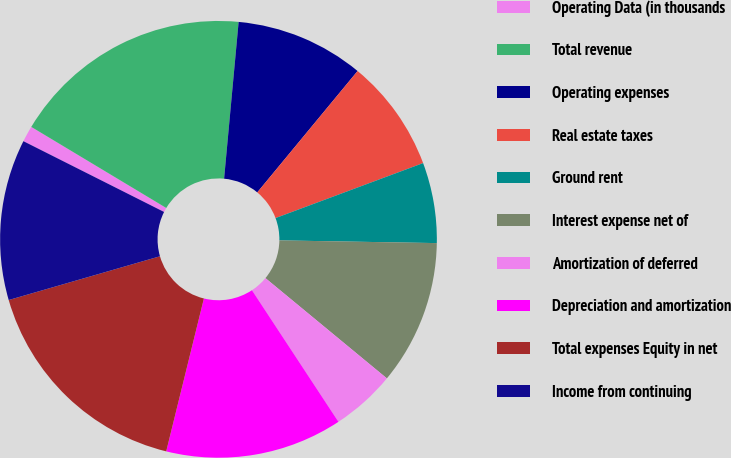Convert chart to OTSL. <chart><loc_0><loc_0><loc_500><loc_500><pie_chart><fcel>Operating Data (in thousands<fcel>Total revenue<fcel>Operating expenses<fcel>Real estate taxes<fcel>Ground rent<fcel>Interest expense net of<fcel>Amortization of deferred<fcel>Depreciation and amortization<fcel>Total expenses Equity in net<fcel>Income from continuing<nl><fcel>1.19%<fcel>17.86%<fcel>9.52%<fcel>8.33%<fcel>5.95%<fcel>10.71%<fcel>4.76%<fcel>13.1%<fcel>16.67%<fcel>11.9%<nl></chart> 